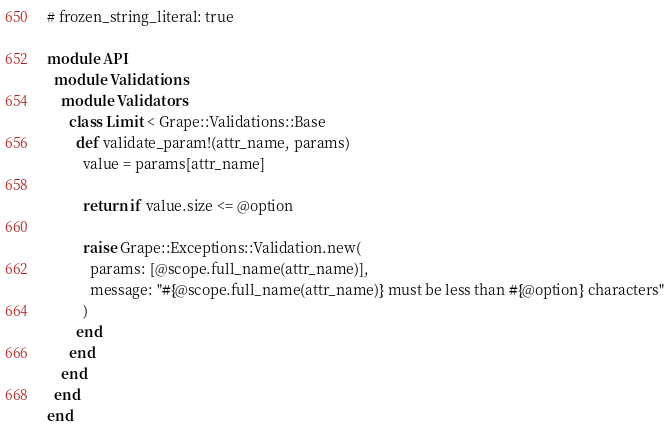<code> <loc_0><loc_0><loc_500><loc_500><_Ruby_># frozen_string_literal: true

module API
  module Validations
    module Validators
      class Limit < Grape::Validations::Base
        def validate_param!(attr_name, params)
          value = params[attr_name]

          return if value.size <= @option

          raise Grape::Exceptions::Validation.new(
            params: [@scope.full_name(attr_name)],
            message: "#{@scope.full_name(attr_name)} must be less than #{@option} characters"
          )
        end
      end
    end
  end
end
</code> 